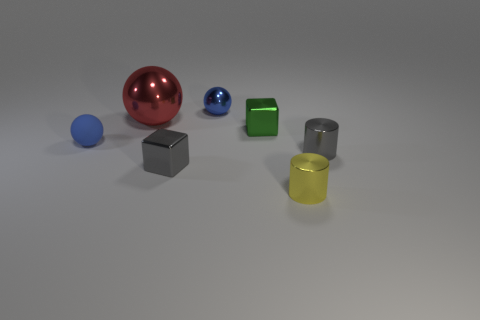Add 2 small cyan shiny cylinders. How many objects exist? 9 Subtract all blocks. How many objects are left? 5 Subtract 0 yellow balls. How many objects are left? 7 Subtract all small gray things. Subtract all big red spheres. How many objects are left? 4 Add 4 red shiny spheres. How many red shiny spheres are left? 5 Add 6 tiny blue rubber things. How many tiny blue rubber things exist? 7 